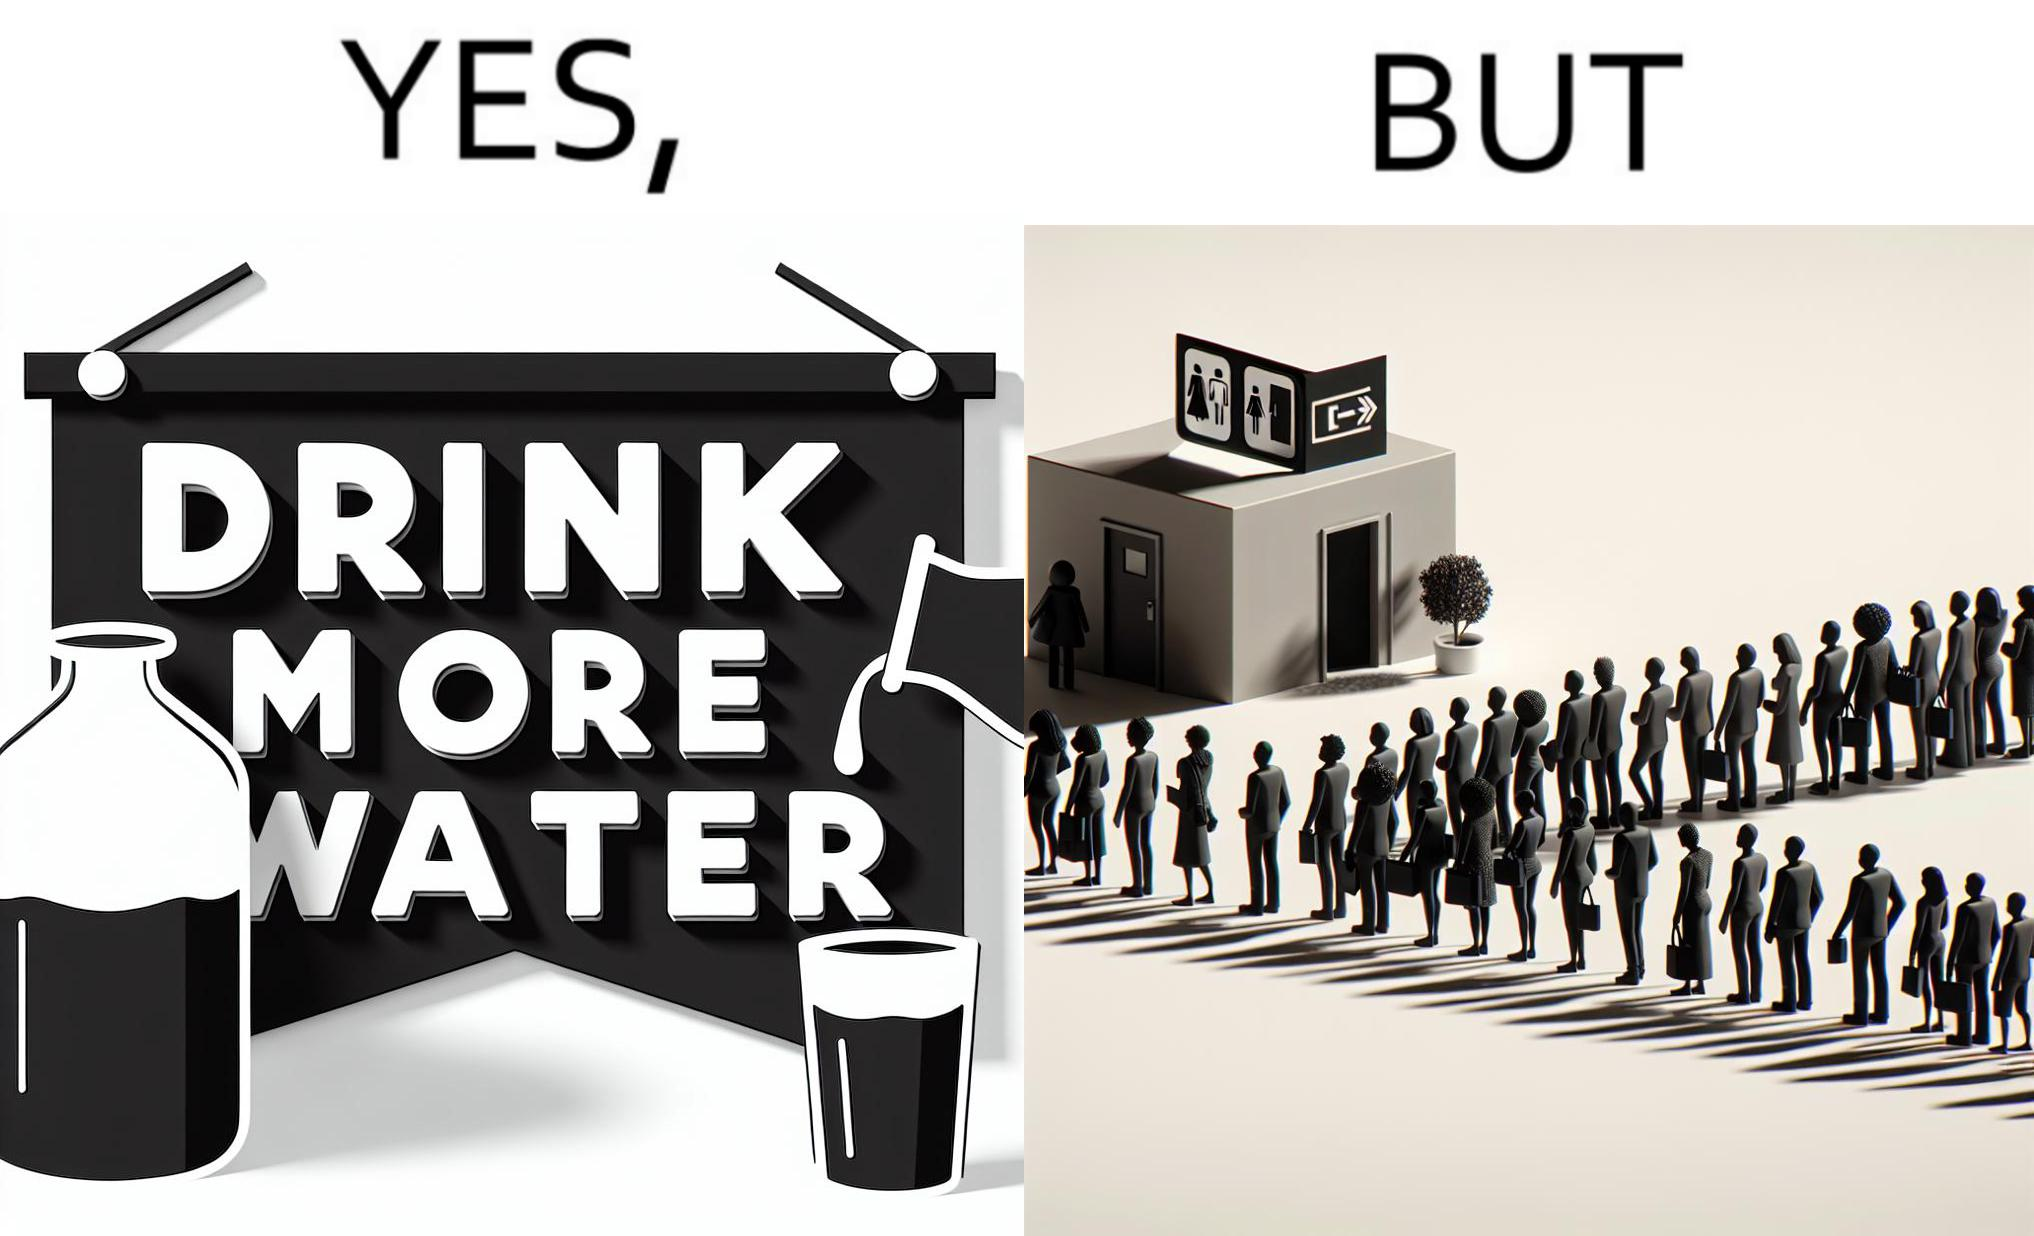Describe what you see in the left and right parts of this image. In the left part of the image: A banner that says "Drink more water" with an image of a jug pouring water into a glass. In the right part of the image: a very long queue in front of the public toilet 